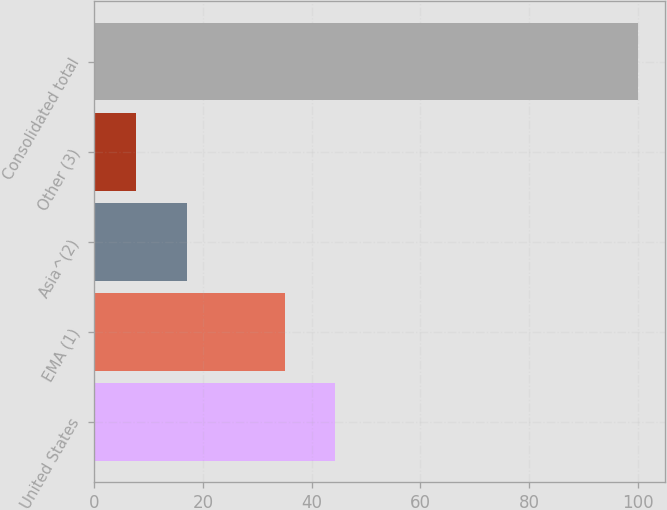Convert chart. <chart><loc_0><loc_0><loc_500><loc_500><bar_chart><fcel>United States<fcel>EMA (1)<fcel>Asia^(2)<fcel>Other (3)<fcel>Consolidated total<nl><fcel>44.32<fcel>35.1<fcel>17.02<fcel>7.8<fcel>100<nl></chart> 